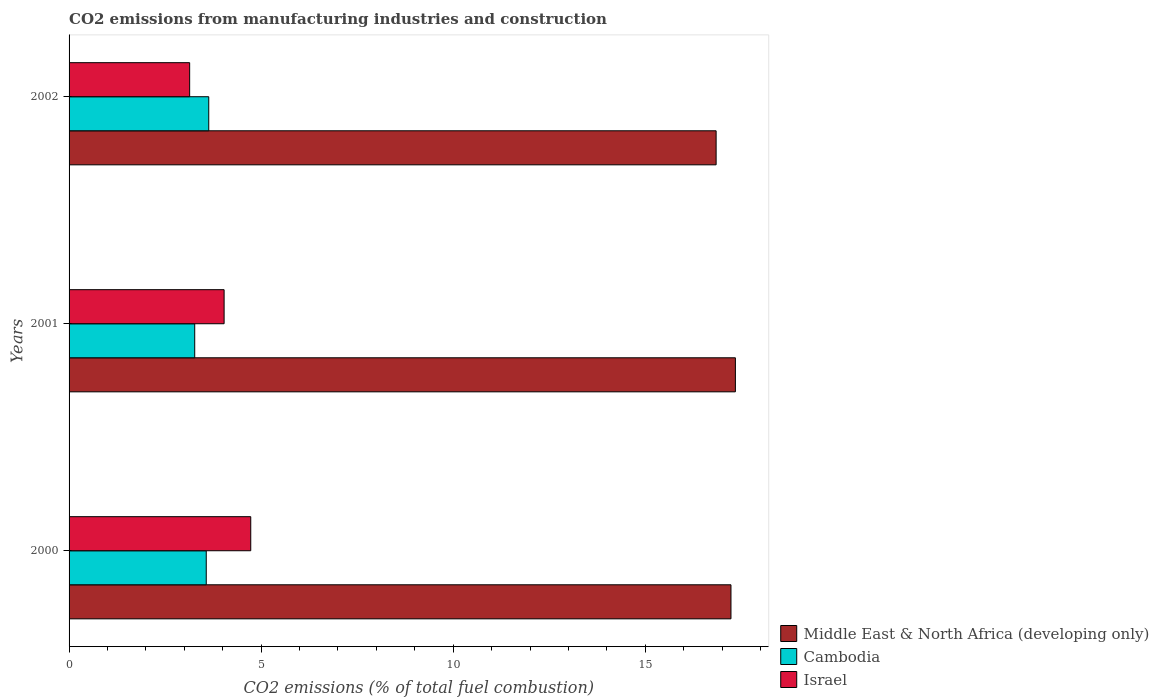Are the number of bars per tick equal to the number of legend labels?
Your response must be concise. Yes. In how many cases, is the number of bars for a given year not equal to the number of legend labels?
Ensure brevity in your answer.  0. What is the amount of CO2 emitted in Cambodia in 2002?
Provide a succinct answer. 3.64. Across all years, what is the maximum amount of CO2 emitted in Middle East & North Africa (developing only)?
Give a very brief answer. 17.35. Across all years, what is the minimum amount of CO2 emitted in Israel?
Your answer should be compact. 3.14. What is the total amount of CO2 emitted in Cambodia in the graph?
Offer a very short reply. 10.48. What is the difference between the amount of CO2 emitted in Israel in 2000 and that in 2001?
Give a very brief answer. 0.69. What is the difference between the amount of CO2 emitted in Middle East & North Africa (developing only) in 2000 and the amount of CO2 emitted in Israel in 2001?
Offer a very short reply. 13.2. What is the average amount of CO2 emitted in Israel per year?
Provide a succinct answer. 3.97. In the year 2001, what is the difference between the amount of CO2 emitted in Cambodia and amount of CO2 emitted in Israel?
Give a very brief answer. -0.77. What is the ratio of the amount of CO2 emitted in Cambodia in 2000 to that in 2002?
Provide a succinct answer. 0.98. What is the difference between the highest and the second highest amount of CO2 emitted in Cambodia?
Keep it short and to the point. 0.06. What is the difference between the highest and the lowest amount of CO2 emitted in Middle East & North Africa (developing only)?
Provide a short and direct response. 0.5. What does the 1st bar from the top in 2001 represents?
Provide a succinct answer. Israel. How many bars are there?
Keep it short and to the point. 9. Are all the bars in the graph horizontal?
Give a very brief answer. Yes. How many years are there in the graph?
Give a very brief answer. 3. What is the difference between two consecutive major ticks on the X-axis?
Offer a very short reply. 5. Are the values on the major ticks of X-axis written in scientific E-notation?
Ensure brevity in your answer.  No. Does the graph contain any zero values?
Provide a short and direct response. No. Where does the legend appear in the graph?
Provide a short and direct response. Bottom right. What is the title of the graph?
Give a very brief answer. CO2 emissions from manufacturing industries and construction. What is the label or title of the X-axis?
Your response must be concise. CO2 emissions (% of total fuel combustion). What is the CO2 emissions (% of total fuel combustion) in Middle East & North Africa (developing only) in 2000?
Your answer should be very brief. 17.23. What is the CO2 emissions (% of total fuel combustion) of Cambodia in 2000?
Offer a terse response. 3.57. What is the CO2 emissions (% of total fuel combustion) in Israel in 2000?
Provide a short and direct response. 4.73. What is the CO2 emissions (% of total fuel combustion) in Middle East & North Africa (developing only) in 2001?
Offer a very short reply. 17.35. What is the CO2 emissions (% of total fuel combustion) in Cambodia in 2001?
Your response must be concise. 3.27. What is the CO2 emissions (% of total fuel combustion) in Israel in 2001?
Give a very brief answer. 4.04. What is the CO2 emissions (% of total fuel combustion) in Middle East & North Africa (developing only) in 2002?
Your answer should be compact. 16.85. What is the CO2 emissions (% of total fuel combustion) of Cambodia in 2002?
Make the answer very short. 3.64. What is the CO2 emissions (% of total fuel combustion) in Israel in 2002?
Make the answer very short. 3.14. Across all years, what is the maximum CO2 emissions (% of total fuel combustion) in Middle East & North Africa (developing only)?
Make the answer very short. 17.35. Across all years, what is the maximum CO2 emissions (% of total fuel combustion) of Cambodia?
Offer a very short reply. 3.64. Across all years, what is the maximum CO2 emissions (% of total fuel combustion) in Israel?
Your answer should be compact. 4.73. Across all years, what is the minimum CO2 emissions (% of total fuel combustion) of Middle East & North Africa (developing only)?
Offer a very short reply. 16.85. Across all years, what is the minimum CO2 emissions (% of total fuel combustion) in Cambodia?
Your response must be concise. 3.27. Across all years, what is the minimum CO2 emissions (% of total fuel combustion) in Israel?
Offer a terse response. 3.14. What is the total CO2 emissions (% of total fuel combustion) in Middle East & North Africa (developing only) in the graph?
Ensure brevity in your answer.  51.42. What is the total CO2 emissions (% of total fuel combustion) of Cambodia in the graph?
Ensure brevity in your answer.  10.48. What is the total CO2 emissions (% of total fuel combustion) of Israel in the graph?
Provide a succinct answer. 11.91. What is the difference between the CO2 emissions (% of total fuel combustion) in Middle East & North Africa (developing only) in 2000 and that in 2001?
Offer a very short reply. -0.12. What is the difference between the CO2 emissions (% of total fuel combustion) of Cambodia in 2000 and that in 2001?
Your response must be concise. 0.3. What is the difference between the CO2 emissions (% of total fuel combustion) of Israel in 2000 and that in 2001?
Keep it short and to the point. 0.69. What is the difference between the CO2 emissions (% of total fuel combustion) in Middle East & North Africa (developing only) in 2000 and that in 2002?
Make the answer very short. 0.39. What is the difference between the CO2 emissions (% of total fuel combustion) of Cambodia in 2000 and that in 2002?
Offer a very short reply. -0.06. What is the difference between the CO2 emissions (% of total fuel combustion) of Israel in 2000 and that in 2002?
Offer a very short reply. 1.59. What is the difference between the CO2 emissions (% of total fuel combustion) of Middle East & North Africa (developing only) in 2001 and that in 2002?
Keep it short and to the point. 0.5. What is the difference between the CO2 emissions (% of total fuel combustion) of Cambodia in 2001 and that in 2002?
Offer a very short reply. -0.37. What is the difference between the CO2 emissions (% of total fuel combustion) of Israel in 2001 and that in 2002?
Give a very brief answer. 0.9. What is the difference between the CO2 emissions (% of total fuel combustion) in Middle East & North Africa (developing only) in 2000 and the CO2 emissions (% of total fuel combustion) in Cambodia in 2001?
Ensure brevity in your answer.  13.96. What is the difference between the CO2 emissions (% of total fuel combustion) in Middle East & North Africa (developing only) in 2000 and the CO2 emissions (% of total fuel combustion) in Israel in 2001?
Your answer should be very brief. 13.2. What is the difference between the CO2 emissions (% of total fuel combustion) of Cambodia in 2000 and the CO2 emissions (% of total fuel combustion) of Israel in 2001?
Provide a succinct answer. -0.46. What is the difference between the CO2 emissions (% of total fuel combustion) of Middle East & North Africa (developing only) in 2000 and the CO2 emissions (% of total fuel combustion) of Cambodia in 2002?
Ensure brevity in your answer.  13.6. What is the difference between the CO2 emissions (% of total fuel combustion) of Middle East & North Africa (developing only) in 2000 and the CO2 emissions (% of total fuel combustion) of Israel in 2002?
Your response must be concise. 14.09. What is the difference between the CO2 emissions (% of total fuel combustion) of Cambodia in 2000 and the CO2 emissions (% of total fuel combustion) of Israel in 2002?
Provide a succinct answer. 0.43. What is the difference between the CO2 emissions (% of total fuel combustion) in Middle East & North Africa (developing only) in 2001 and the CO2 emissions (% of total fuel combustion) in Cambodia in 2002?
Offer a terse response. 13.71. What is the difference between the CO2 emissions (% of total fuel combustion) of Middle East & North Africa (developing only) in 2001 and the CO2 emissions (% of total fuel combustion) of Israel in 2002?
Your response must be concise. 14.21. What is the difference between the CO2 emissions (% of total fuel combustion) of Cambodia in 2001 and the CO2 emissions (% of total fuel combustion) of Israel in 2002?
Offer a terse response. 0.13. What is the average CO2 emissions (% of total fuel combustion) in Middle East & North Africa (developing only) per year?
Give a very brief answer. 17.14. What is the average CO2 emissions (% of total fuel combustion) in Cambodia per year?
Provide a short and direct response. 3.49. What is the average CO2 emissions (% of total fuel combustion) in Israel per year?
Offer a very short reply. 3.97. In the year 2000, what is the difference between the CO2 emissions (% of total fuel combustion) of Middle East & North Africa (developing only) and CO2 emissions (% of total fuel combustion) of Cambodia?
Keep it short and to the point. 13.66. In the year 2000, what is the difference between the CO2 emissions (% of total fuel combustion) of Middle East & North Africa (developing only) and CO2 emissions (% of total fuel combustion) of Israel?
Offer a terse response. 12.5. In the year 2000, what is the difference between the CO2 emissions (% of total fuel combustion) of Cambodia and CO2 emissions (% of total fuel combustion) of Israel?
Ensure brevity in your answer.  -1.16. In the year 2001, what is the difference between the CO2 emissions (% of total fuel combustion) of Middle East & North Africa (developing only) and CO2 emissions (% of total fuel combustion) of Cambodia?
Make the answer very short. 14.08. In the year 2001, what is the difference between the CO2 emissions (% of total fuel combustion) of Middle East & North Africa (developing only) and CO2 emissions (% of total fuel combustion) of Israel?
Provide a short and direct response. 13.31. In the year 2001, what is the difference between the CO2 emissions (% of total fuel combustion) of Cambodia and CO2 emissions (% of total fuel combustion) of Israel?
Provide a short and direct response. -0.77. In the year 2002, what is the difference between the CO2 emissions (% of total fuel combustion) of Middle East & North Africa (developing only) and CO2 emissions (% of total fuel combustion) of Cambodia?
Ensure brevity in your answer.  13.21. In the year 2002, what is the difference between the CO2 emissions (% of total fuel combustion) of Middle East & North Africa (developing only) and CO2 emissions (% of total fuel combustion) of Israel?
Offer a very short reply. 13.71. In the year 2002, what is the difference between the CO2 emissions (% of total fuel combustion) in Cambodia and CO2 emissions (% of total fuel combustion) in Israel?
Make the answer very short. 0.5. What is the ratio of the CO2 emissions (% of total fuel combustion) in Cambodia in 2000 to that in 2001?
Give a very brief answer. 1.09. What is the ratio of the CO2 emissions (% of total fuel combustion) of Israel in 2000 to that in 2001?
Make the answer very short. 1.17. What is the ratio of the CO2 emissions (% of total fuel combustion) in Middle East & North Africa (developing only) in 2000 to that in 2002?
Ensure brevity in your answer.  1.02. What is the ratio of the CO2 emissions (% of total fuel combustion) in Cambodia in 2000 to that in 2002?
Provide a succinct answer. 0.98. What is the ratio of the CO2 emissions (% of total fuel combustion) of Israel in 2000 to that in 2002?
Keep it short and to the point. 1.51. What is the ratio of the CO2 emissions (% of total fuel combustion) of Middle East & North Africa (developing only) in 2001 to that in 2002?
Your answer should be compact. 1.03. What is the ratio of the CO2 emissions (% of total fuel combustion) in Cambodia in 2001 to that in 2002?
Offer a very short reply. 0.9. What is the difference between the highest and the second highest CO2 emissions (% of total fuel combustion) of Middle East & North Africa (developing only)?
Give a very brief answer. 0.12. What is the difference between the highest and the second highest CO2 emissions (% of total fuel combustion) in Cambodia?
Make the answer very short. 0.06. What is the difference between the highest and the second highest CO2 emissions (% of total fuel combustion) in Israel?
Make the answer very short. 0.69. What is the difference between the highest and the lowest CO2 emissions (% of total fuel combustion) in Middle East & North Africa (developing only)?
Provide a short and direct response. 0.5. What is the difference between the highest and the lowest CO2 emissions (% of total fuel combustion) in Cambodia?
Your response must be concise. 0.37. What is the difference between the highest and the lowest CO2 emissions (% of total fuel combustion) of Israel?
Offer a very short reply. 1.59. 